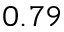Convert formula to latex. <formula><loc_0><loc_0><loc_500><loc_500>0 . 7 9</formula> 